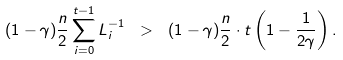<formula> <loc_0><loc_0><loc_500><loc_500>( 1 - \gamma ) \frac { n } { 2 } \sum _ { i = 0 } ^ { t - 1 } L _ { i } ^ { - 1 } \ > \ ( 1 - \gamma ) \frac { n } { 2 } \cdot t \left ( 1 - \frac { 1 } { 2 \gamma } \right ) .</formula> 